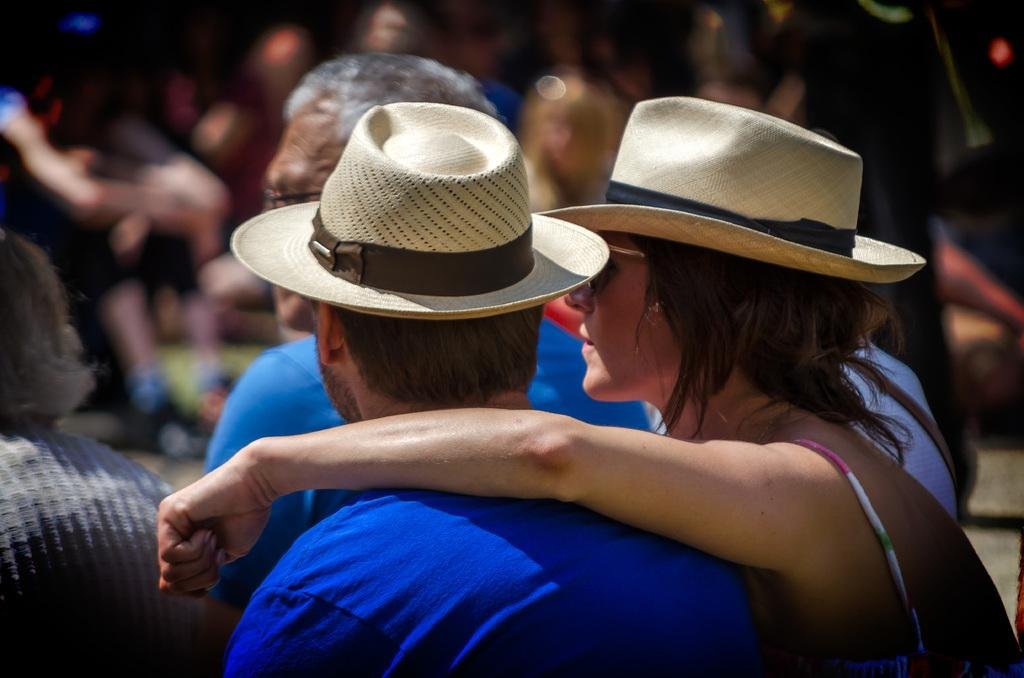How many people are in the image? There is a group of people in the image. Can you describe the clothing of one of the individuals? One person is wearing a blue shirt and a cream color cap. What can be said about the background of the image? The background of the image is blurred. How many geese are visible in the image? There are no geese present in the image. Is there a scale for weighing objects in the image? There is no scale visible in the image. 